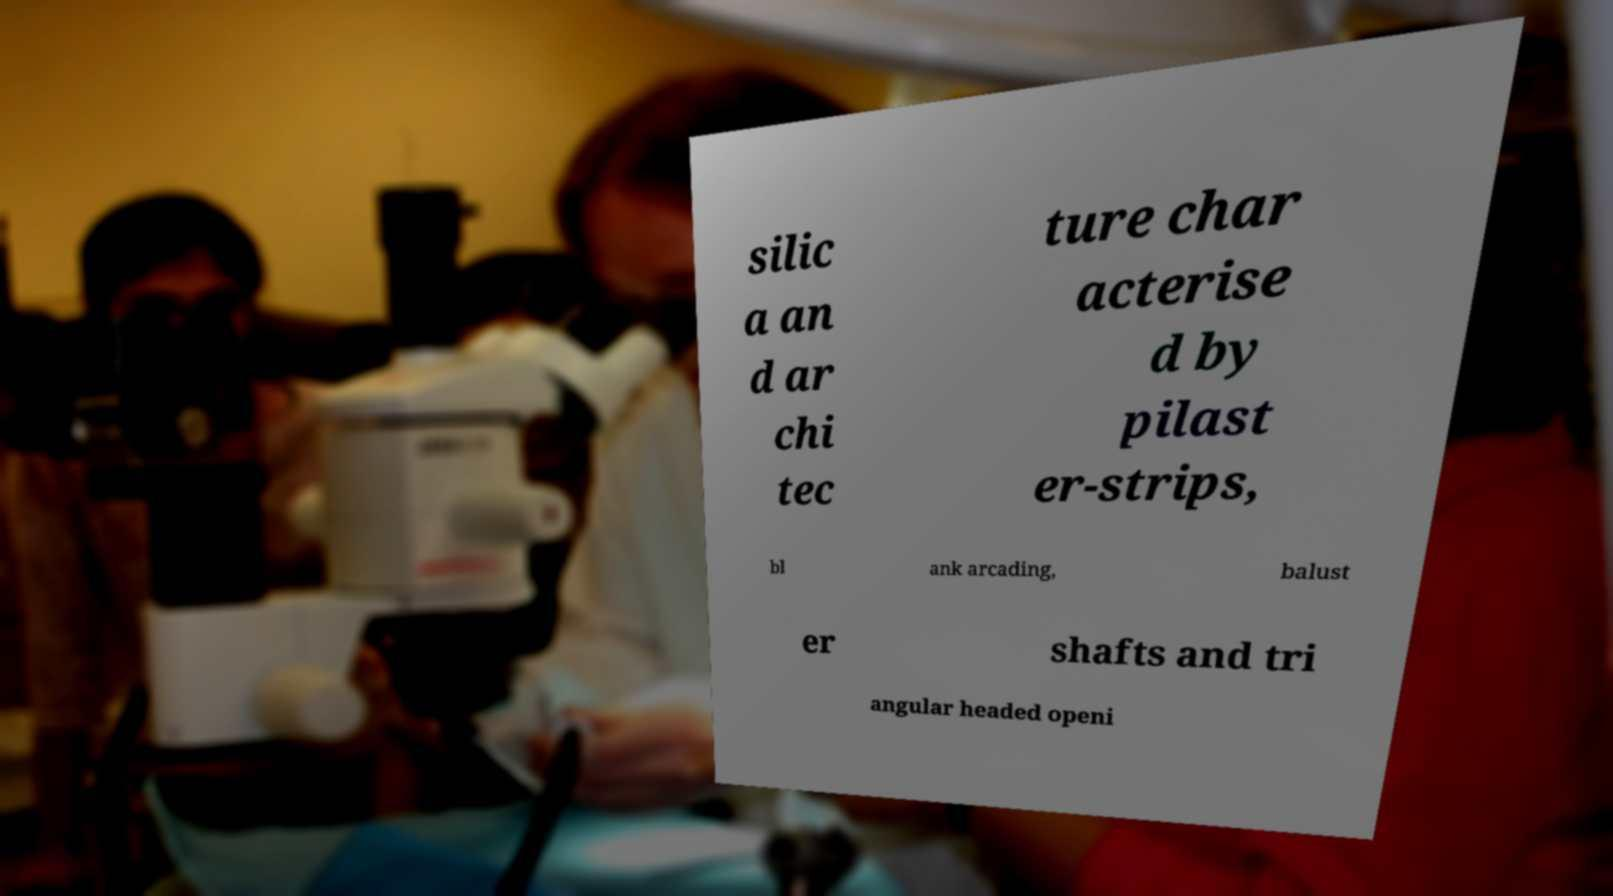Please identify and transcribe the text found in this image. silic a an d ar chi tec ture char acterise d by pilast er-strips, bl ank arcading, balust er shafts and tri angular headed openi 